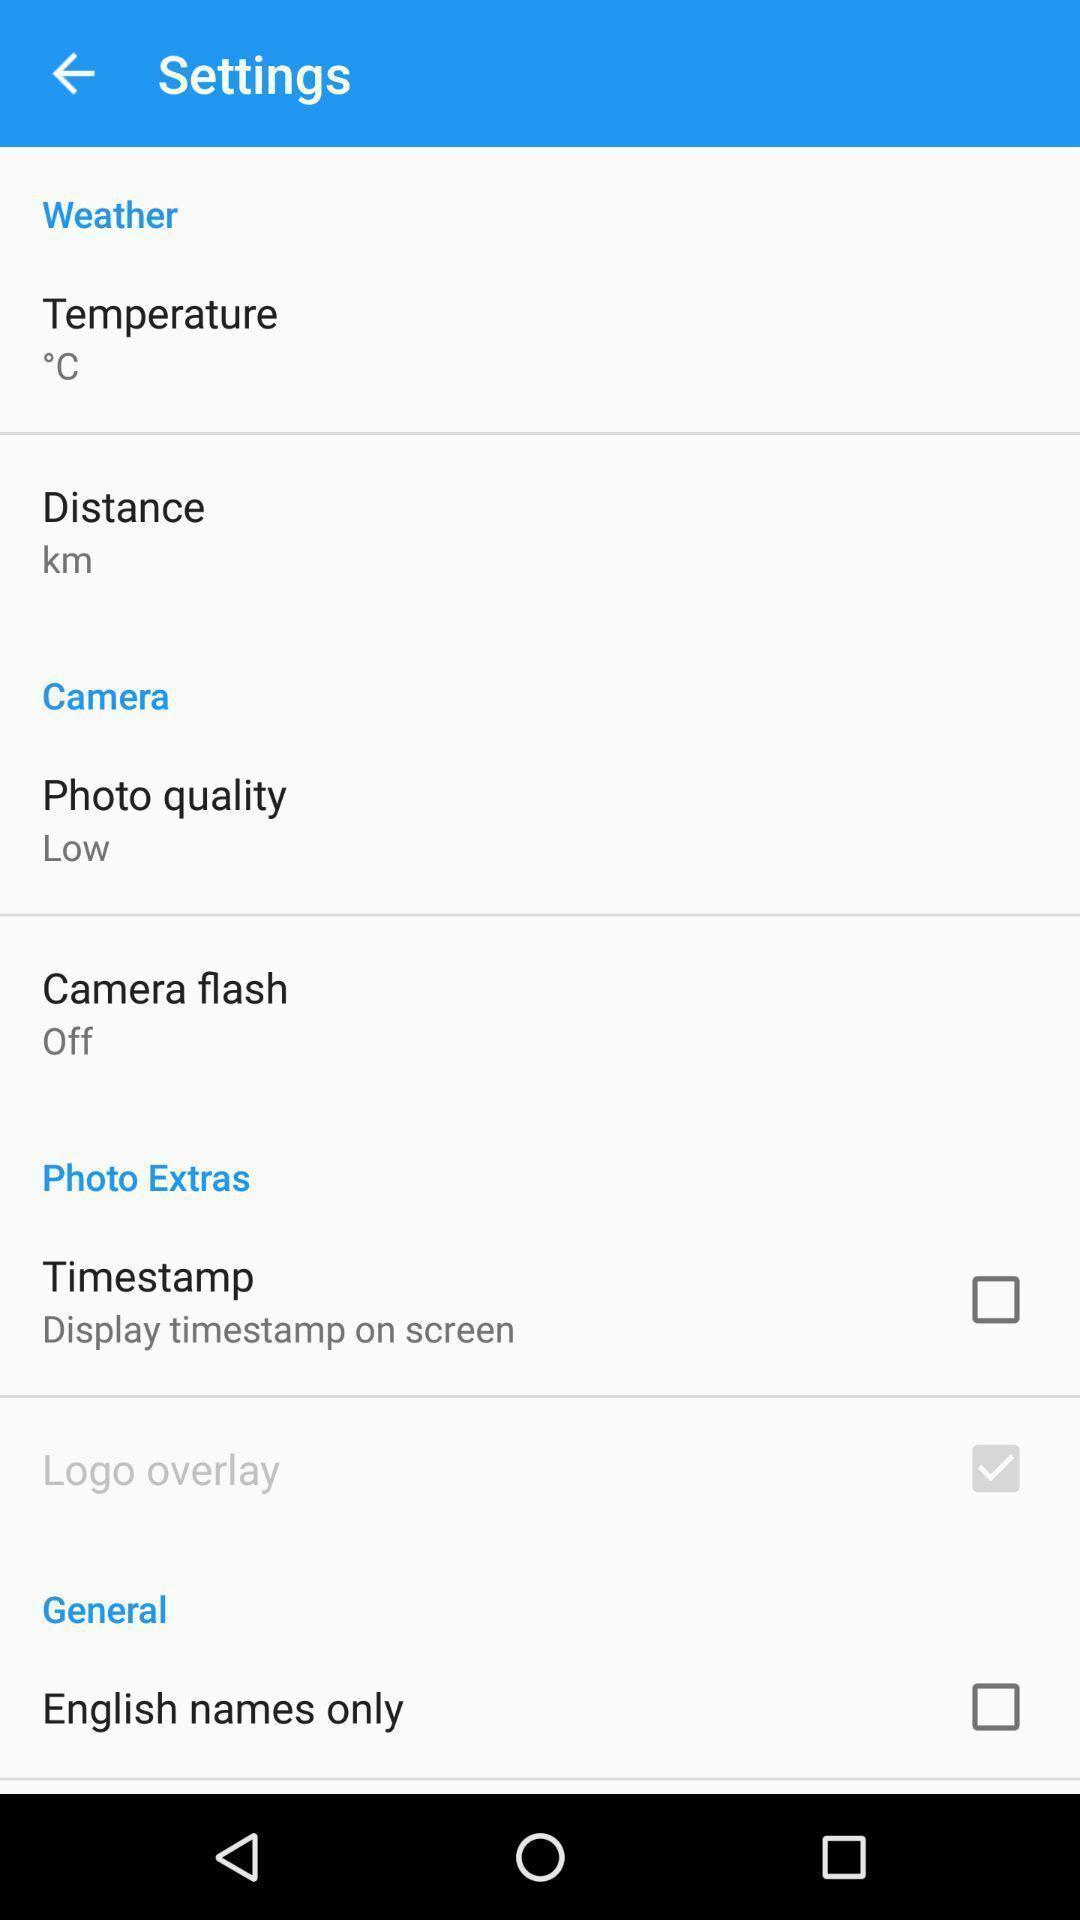Provide a textual representation of this image. Settings page. 